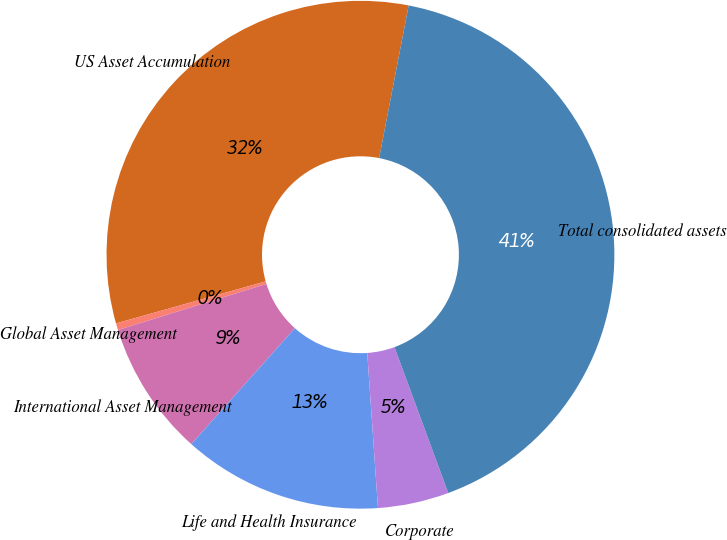Convert chart to OTSL. <chart><loc_0><loc_0><loc_500><loc_500><pie_chart><fcel>US Asset Accumulation<fcel>Global Asset Management<fcel>International Asset Management<fcel>Life and Health Insurance<fcel>Corporate<fcel>Total consolidated assets<nl><fcel>32.4%<fcel>0.43%<fcel>8.61%<fcel>12.7%<fcel>4.52%<fcel>41.34%<nl></chart> 